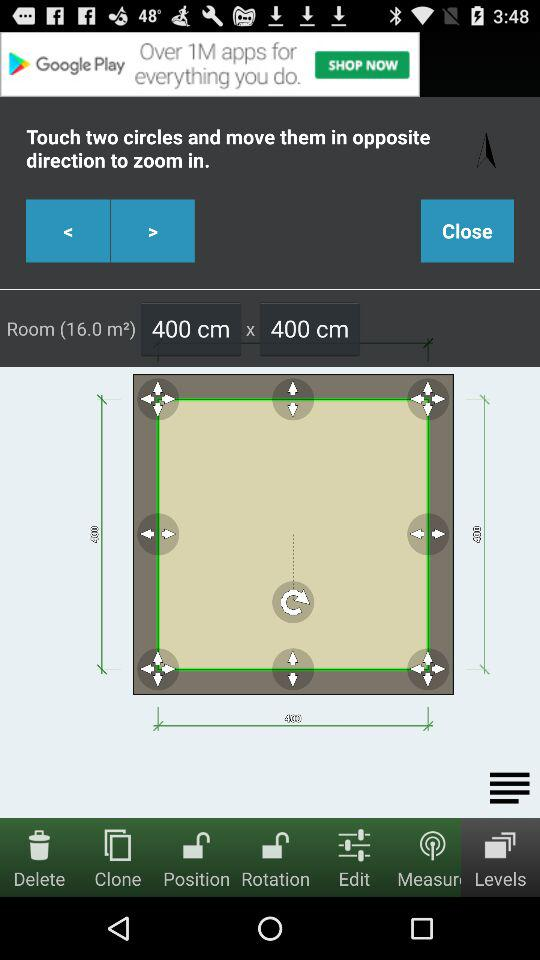What's the room size? The room size is 16.0 m². 